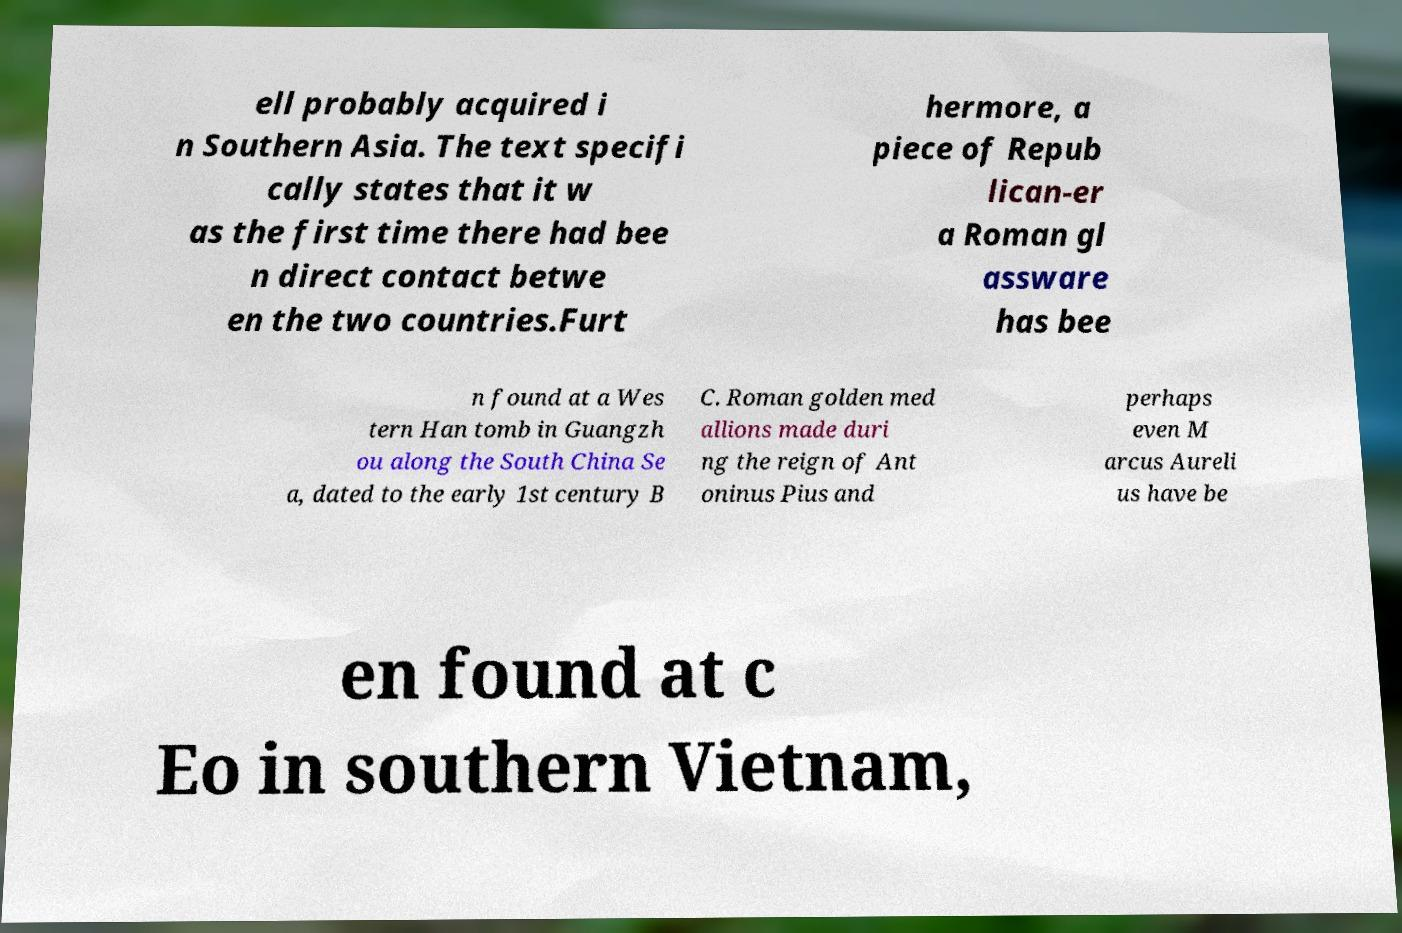For documentation purposes, I need the text within this image transcribed. Could you provide that? ell probably acquired i n Southern Asia. The text specifi cally states that it w as the first time there had bee n direct contact betwe en the two countries.Furt hermore, a piece of Repub lican-er a Roman gl assware has bee n found at a Wes tern Han tomb in Guangzh ou along the South China Se a, dated to the early 1st century B C. Roman golden med allions made duri ng the reign of Ant oninus Pius and perhaps even M arcus Aureli us have be en found at c Eo in southern Vietnam, 